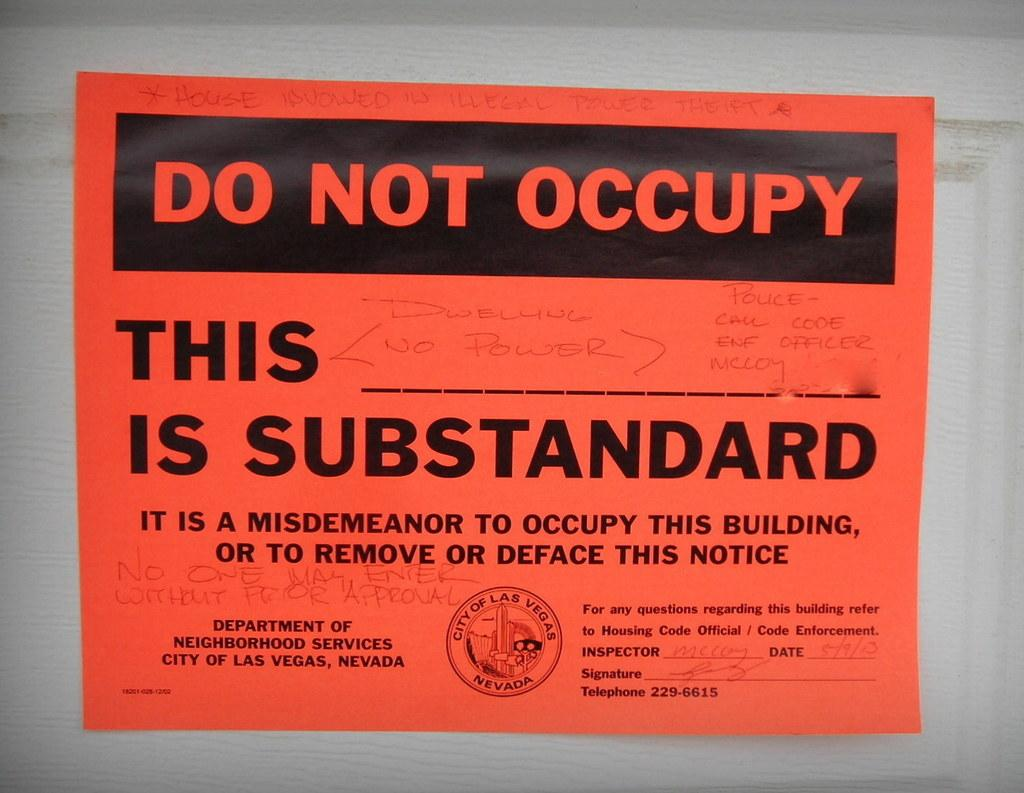<image>
Write a terse but informative summary of the picture. A piece of paper that says "Do not occupy" on it 